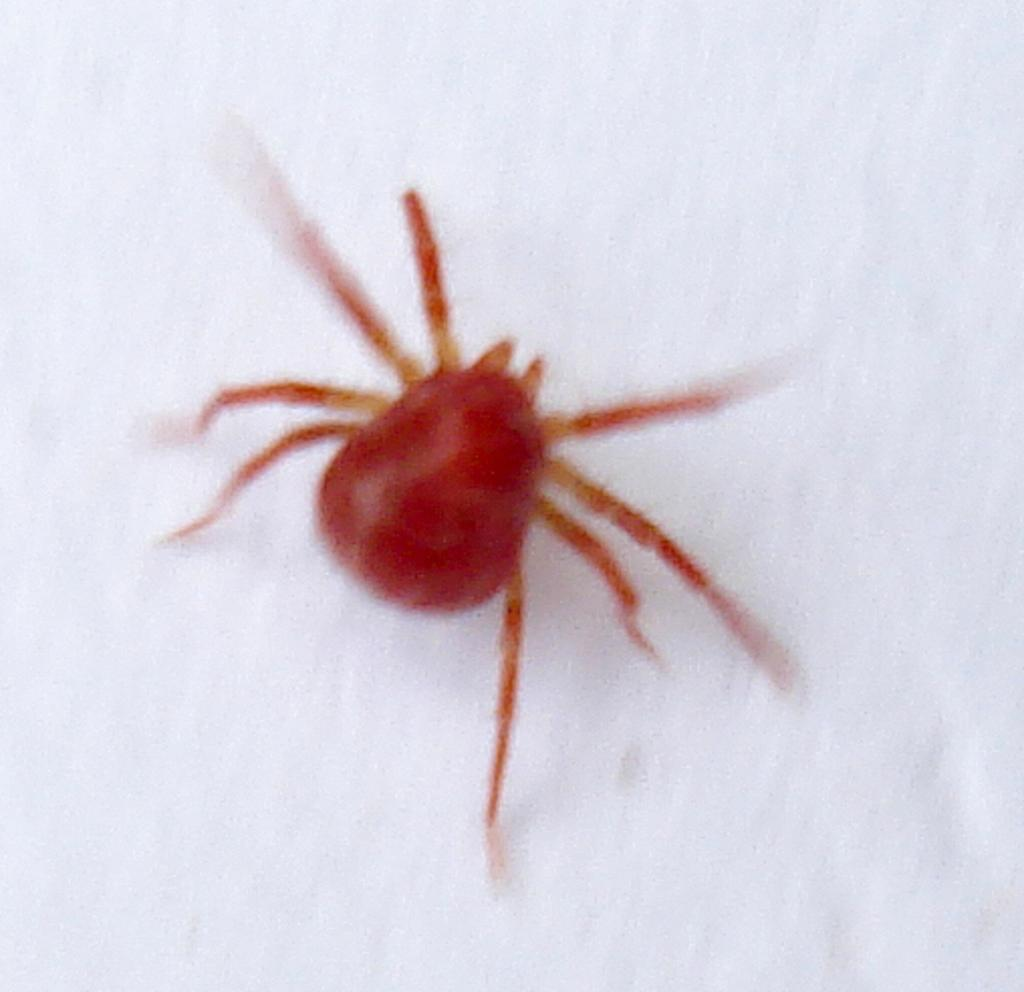What is the color of the spider in the picture? The spider in the picture is red. What color is the background behind the spider? The background behind the spider is white. What type of wood is the spider using to build its web in the image? There is no wood or web present in the image; it only features a red spider on a white background. 